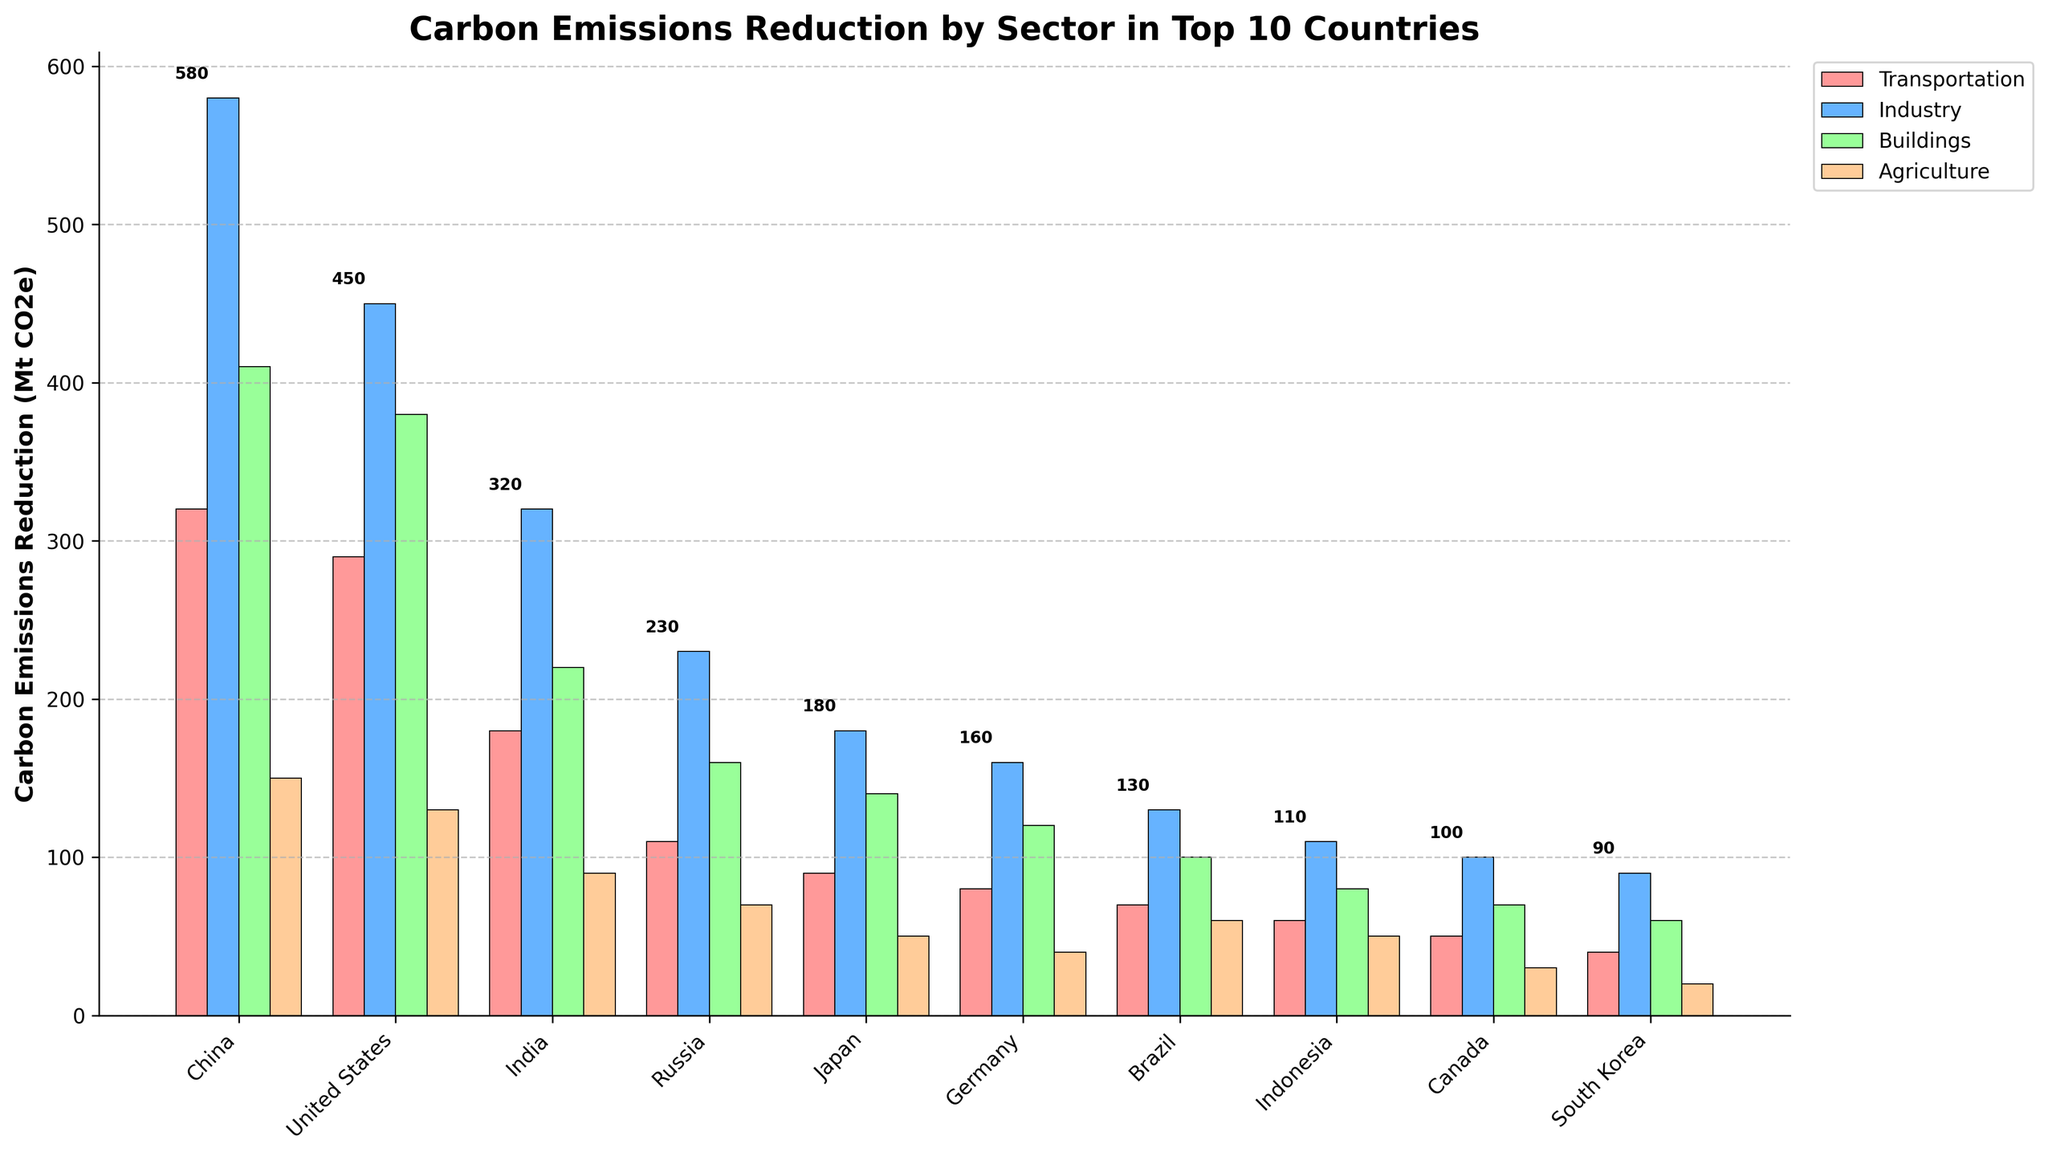What is the country with the highest carbon emissions reduction in the industry sector? Look at the heights of the bars in the "Industry" category. Identify the tallest bar, which belongs to China with a value of 580.
Answer: China What is the total carbon emissions reduction in the transportation sector across all the countries? Add the values for the transportation sector from all countries: 320 (China) + 290 (United States) + 180 (India) + 110 (Russia) + 90 (Japan) + 80 (Germany) + 70 (Brazil) + 60 (Indonesia) + 50 (Canada) + 40 (South Korea) = 1290.
Answer: 1290 Which sector contributes the least to carbon emissions reduction in Canada? Compare the heights of the bars for Canada in all sectors. The shortest bar corresponds to the Agriculture sector with a value of 30.
Answer: Agriculture Which two countries have an equal amount of carbon emissions reduction in the agriculture sector? Look for bars with the same height in the Agriculture sector. Both Japan and Indonesia have bars of 50.
Answer: Japan and Indonesia What is the average carbon emissions reduction in the buildings sector across the top 3 countries? Add the values for the buildings sector for China, United States, and India: 410 + 380 + 220 = 1010. Then divide by 3: 1010/3 = 336.67.
Answer: 336.67 Which country has the second highest carbon emissions reduction in the transportation sector? Order the values for the transportation sector from highest to lowest. First is China (320), second is the United States (290).
Answer: United States By how much does the carbon emissions reduction in the industry sector of the United States differ from that of India? Subtract the value for India from the value for the United States in the Industry sector: 450 (United States) - 320 (India) = 130.
Answer: 130 Which sector in Brazil has a higher carbon emissions reduction than the same sector in Indonesia? Compare the bars for each sector between Brazil and Indonesia. In both the Agriculture (60 vs 50) and Buildings (100 vs 80) sectors, Brazil's reduction is higher.
Answer: Agriculture and Buildings What is the combined carbon emissions reduction for the agriculture sector in South Korea and Japan? Add the values for the agriculture sector in both countries: 20 (South Korea) + 50 (Japan) = 70.
Answer: 70 Which sector has the highest overall carbon emissions reduction across all 10 countries? Sum the values for each sector across all countries and compare. Industry: 580+450+320+230+180+160+130+110+100+90=2350, Transportation: 1290, Buildings: 1670, Agriculture: 690. The highest is the Industry sector with 2350.
Answer: Industry 